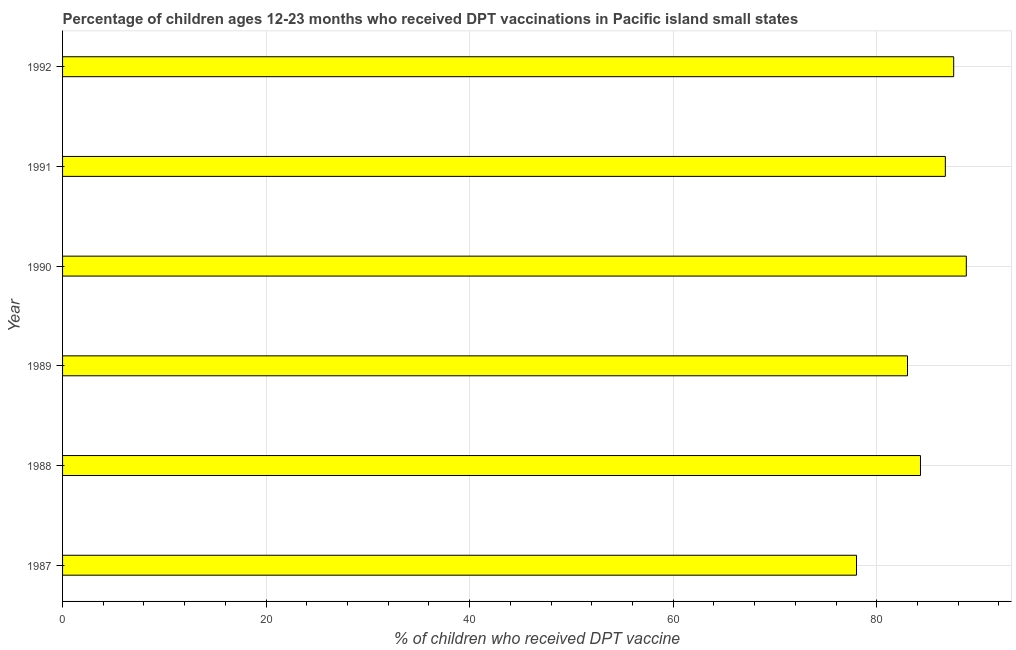Does the graph contain any zero values?
Keep it short and to the point. No. What is the title of the graph?
Ensure brevity in your answer.  Percentage of children ages 12-23 months who received DPT vaccinations in Pacific island small states. What is the label or title of the X-axis?
Your answer should be very brief. % of children who received DPT vaccine. What is the percentage of children who received dpt vaccine in 1987?
Provide a succinct answer. 78.01. Across all years, what is the maximum percentage of children who received dpt vaccine?
Offer a terse response. 88.8. Across all years, what is the minimum percentage of children who received dpt vaccine?
Provide a short and direct response. 78.01. In which year was the percentage of children who received dpt vaccine maximum?
Ensure brevity in your answer.  1990. What is the sum of the percentage of children who received dpt vaccine?
Give a very brief answer. 508.43. What is the difference between the percentage of children who received dpt vaccine in 1989 and 1990?
Your response must be concise. -5.78. What is the average percentage of children who received dpt vaccine per year?
Give a very brief answer. 84.74. What is the median percentage of children who received dpt vaccine?
Your response must be concise. 85.52. What is the ratio of the percentage of children who received dpt vaccine in 1988 to that in 1992?
Keep it short and to the point. 0.96. Is the percentage of children who received dpt vaccine in 1987 less than that in 1990?
Offer a terse response. Yes. What is the difference between the highest and the second highest percentage of children who received dpt vaccine?
Your answer should be very brief. 1.24. What is the difference between the highest and the lowest percentage of children who received dpt vaccine?
Ensure brevity in your answer.  10.79. How many years are there in the graph?
Provide a short and direct response. 6. What is the difference between two consecutive major ticks on the X-axis?
Your response must be concise. 20. What is the % of children who received DPT vaccine in 1987?
Your answer should be very brief. 78.01. What is the % of children who received DPT vaccine in 1988?
Provide a short and direct response. 84.3. What is the % of children who received DPT vaccine of 1989?
Give a very brief answer. 83.02. What is the % of children who received DPT vaccine in 1990?
Give a very brief answer. 88.8. What is the % of children who received DPT vaccine in 1991?
Give a very brief answer. 86.74. What is the % of children who received DPT vaccine in 1992?
Ensure brevity in your answer.  87.56. What is the difference between the % of children who received DPT vaccine in 1987 and 1988?
Offer a terse response. -6.29. What is the difference between the % of children who received DPT vaccine in 1987 and 1989?
Your response must be concise. -5.01. What is the difference between the % of children who received DPT vaccine in 1987 and 1990?
Your answer should be very brief. -10.79. What is the difference between the % of children who received DPT vaccine in 1987 and 1991?
Ensure brevity in your answer.  -8.73. What is the difference between the % of children who received DPT vaccine in 1987 and 1992?
Provide a succinct answer. -9.55. What is the difference between the % of children who received DPT vaccine in 1988 and 1989?
Ensure brevity in your answer.  1.28. What is the difference between the % of children who received DPT vaccine in 1988 and 1990?
Make the answer very short. -4.5. What is the difference between the % of children who received DPT vaccine in 1988 and 1991?
Provide a short and direct response. -2.44. What is the difference between the % of children who received DPT vaccine in 1988 and 1992?
Provide a succinct answer. -3.26. What is the difference between the % of children who received DPT vaccine in 1989 and 1990?
Ensure brevity in your answer.  -5.78. What is the difference between the % of children who received DPT vaccine in 1989 and 1991?
Offer a terse response. -3.72. What is the difference between the % of children who received DPT vaccine in 1989 and 1992?
Give a very brief answer. -4.54. What is the difference between the % of children who received DPT vaccine in 1990 and 1991?
Ensure brevity in your answer.  2.06. What is the difference between the % of children who received DPT vaccine in 1990 and 1992?
Give a very brief answer. 1.24. What is the difference between the % of children who received DPT vaccine in 1991 and 1992?
Your response must be concise. -0.82. What is the ratio of the % of children who received DPT vaccine in 1987 to that in 1988?
Your response must be concise. 0.93. What is the ratio of the % of children who received DPT vaccine in 1987 to that in 1990?
Your answer should be very brief. 0.88. What is the ratio of the % of children who received DPT vaccine in 1987 to that in 1991?
Your response must be concise. 0.9. What is the ratio of the % of children who received DPT vaccine in 1987 to that in 1992?
Your answer should be very brief. 0.89. What is the ratio of the % of children who received DPT vaccine in 1988 to that in 1989?
Your answer should be compact. 1.01. What is the ratio of the % of children who received DPT vaccine in 1988 to that in 1990?
Provide a short and direct response. 0.95. What is the ratio of the % of children who received DPT vaccine in 1988 to that in 1991?
Provide a succinct answer. 0.97. What is the ratio of the % of children who received DPT vaccine in 1988 to that in 1992?
Your answer should be very brief. 0.96. What is the ratio of the % of children who received DPT vaccine in 1989 to that in 1990?
Ensure brevity in your answer.  0.94. What is the ratio of the % of children who received DPT vaccine in 1989 to that in 1992?
Offer a terse response. 0.95. 